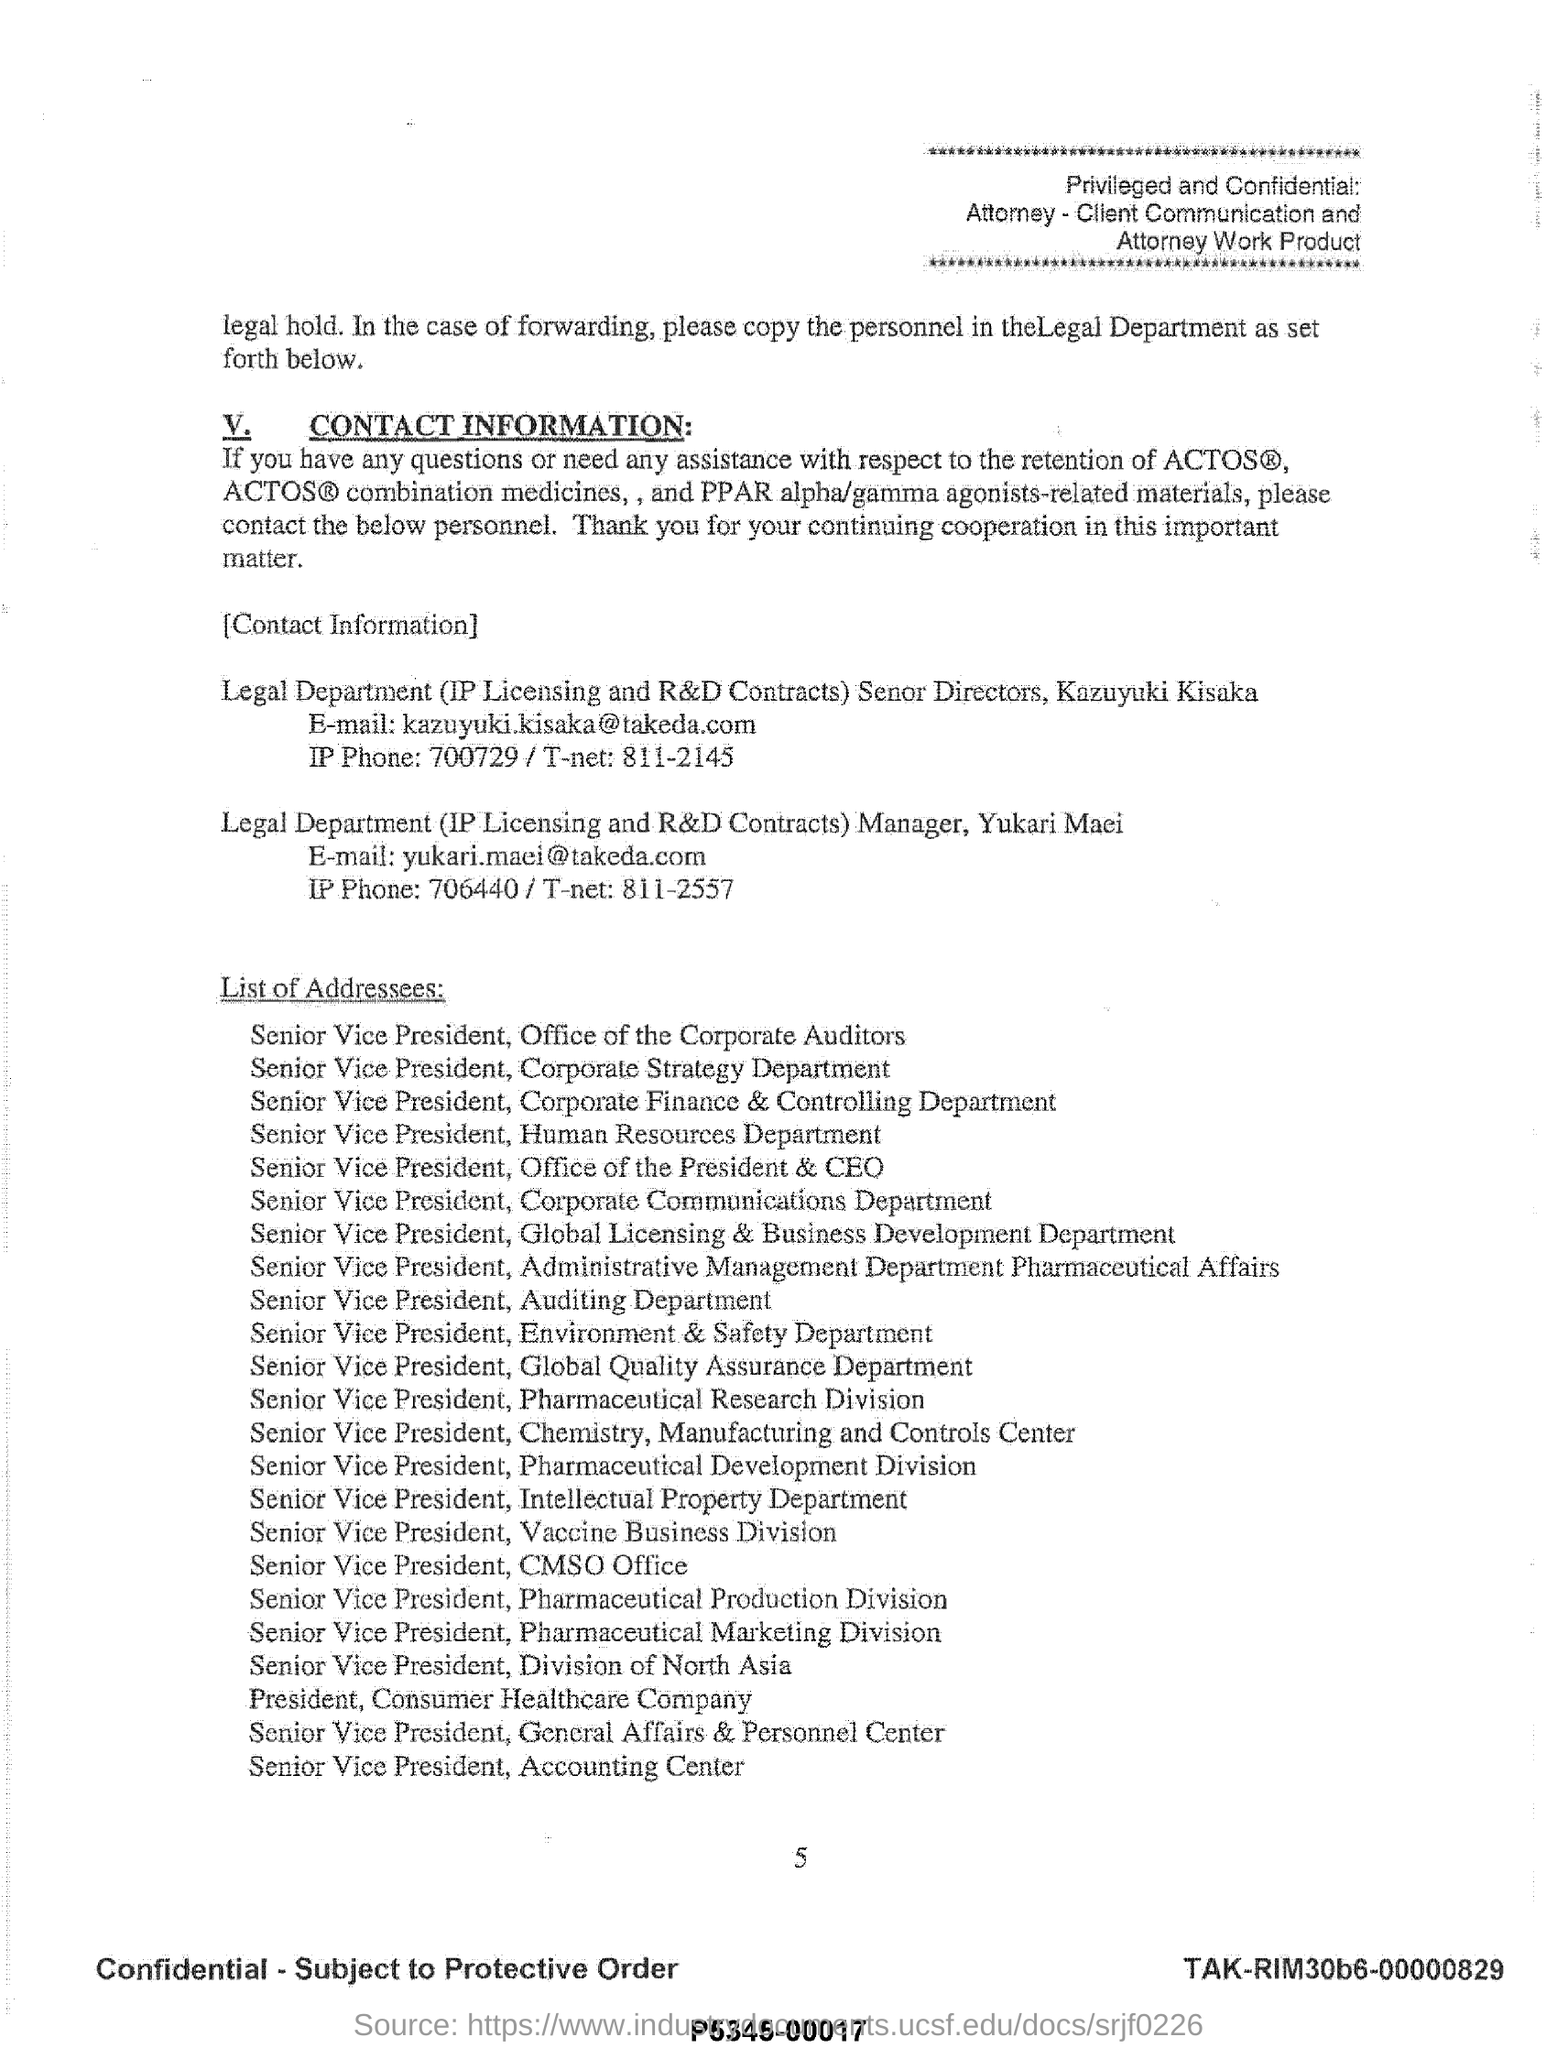Draw attention to some important aspects in this diagram. The 23rd addressee mentioned in the list is Senior Vice President, Accounting Center. 